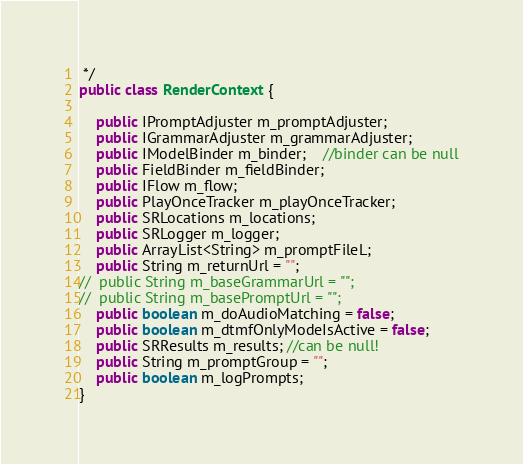<code> <loc_0><loc_0><loc_500><loc_500><_Java_> */
public class RenderContext {

	public IPromptAdjuster m_promptAdjuster;
	public IGrammarAdjuster m_grammarAdjuster;
	public IModelBinder m_binder;  	//binder can be null
	public FieldBinder m_fieldBinder;
	public IFlow m_flow;
	public PlayOnceTracker m_playOnceTracker;
	public SRLocations m_locations;
	public SRLogger m_logger;
	public ArrayList<String> m_promptFileL;
	public String m_returnUrl = "";
//	public String m_baseGrammarUrl = "";
//	public String m_basePromptUrl = "";
	public boolean m_doAudioMatching = false;
	public boolean m_dtmfOnlyModeIsActive = false;
	public SRResults m_results; //can be null!
	public String m_promptGroup = "";
	public boolean m_logPrompts;
}
</code> 